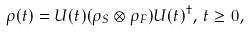Convert formula to latex. <formula><loc_0><loc_0><loc_500><loc_500>\rho ( t ) = U ( t ) ( \rho _ { S } \otimes \rho _ { F } ) U ( t ) ^ { \dagger } , \, t \geq 0 ,</formula> 